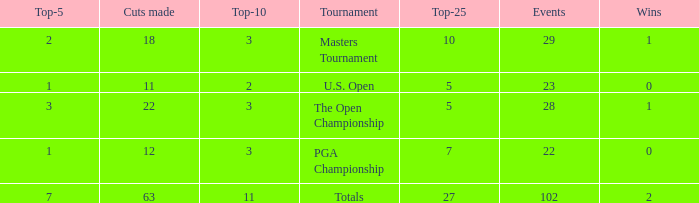How many top 10s linked with 3 top 5s and fewer than 22 cuts made? None. Could you parse the entire table? {'header': ['Top-5', 'Cuts made', 'Top-10', 'Tournament', 'Top-25', 'Events', 'Wins'], 'rows': [['2', '18', '3', 'Masters Tournament', '10', '29', '1'], ['1', '11', '2', 'U.S. Open', '5', '23', '0'], ['3', '22', '3', 'The Open Championship', '5', '28', '1'], ['1', '12', '3', 'PGA Championship', '7', '22', '0'], ['7', '63', '11', 'Totals', '27', '102', '2']]} 